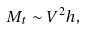Convert formula to latex. <formula><loc_0><loc_0><loc_500><loc_500>M _ { t } \sim V ^ { 2 } h ,</formula> 